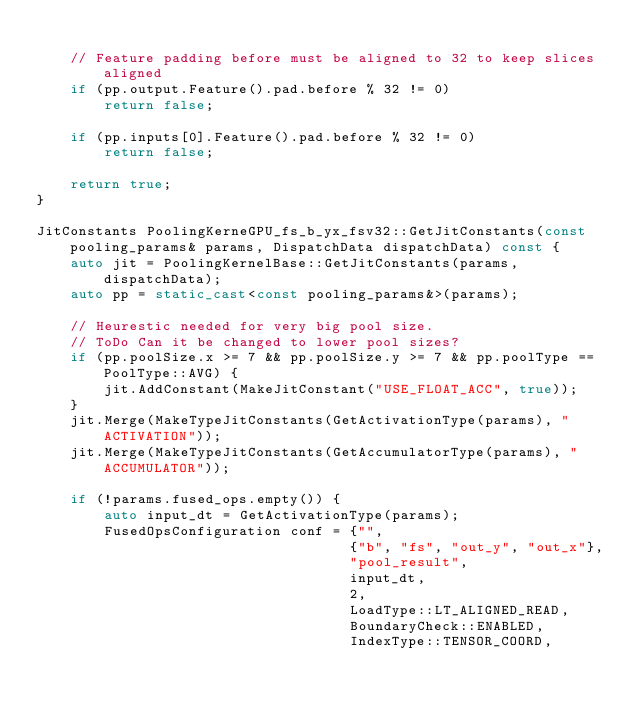Convert code to text. <code><loc_0><loc_0><loc_500><loc_500><_C++_>
    // Feature padding before must be aligned to 32 to keep slices aligned
    if (pp.output.Feature().pad.before % 32 != 0)
        return false;

    if (pp.inputs[0].Feature().pad.before % 32 != 0)
        return false;

    return true;
}

JitConstants PoolingKerneGPU_fs_b_yx_fsv32::GetJitConstants(const pooling_params& params, DispatchData dispatchData) const {
    auto jit = PoolingKernelBase::GetJitConstants(params, dispatchData);
    auto pp = static_cast<const pooling_params&>(params);

    // Heurestic needed for very big pool size.
    // ToDo Can it be changed to lower pool sizes?
    if (pp.poolSize.x >= 7 && pp.poolSize.y >= 7 && pp.poolType == PoolType::AVG) {
        jit.AddConstant(MakeJitConstant("USE_FLOAT_ACC", true));
    }
    jit.Merge(MakeTypeJitConstants(GetActivationType(params), "ACTIVATION"));
    jit.Merge(MakeTypeJitConstants(GetAccumulatorType(params), "ACCUMULATOR"));

    if (!params.fused_ops.empty()) {
        auto input_dt = GetActivationType(params);
        FusedOpsConfiguration conf = {"",
                                     {"b", "fs", "out_y", "out_x"},
                                     "pool_result",
                                     input_dt,
                                     2,
                                     LoadType::LT_ALIGNED_READ,
                                     BoundaryCheck::ENABLED,
                                     IndexType::TENSOR_COORD,</code> 